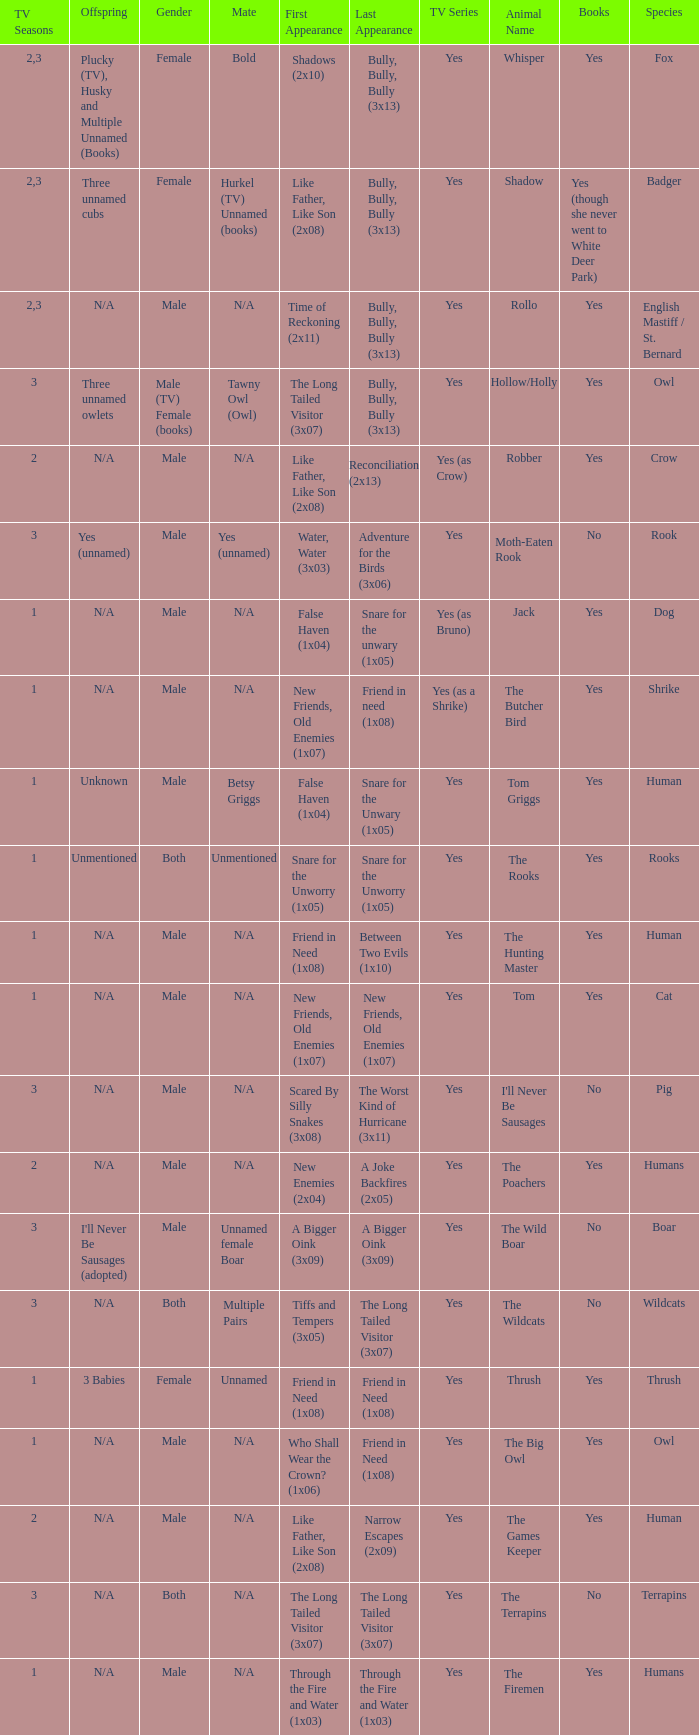What is the mate for Last Appearance of bully, bully, bully (3x13) for the animal named hollow/holly later than season 1? Tawny Owl (Owl). 